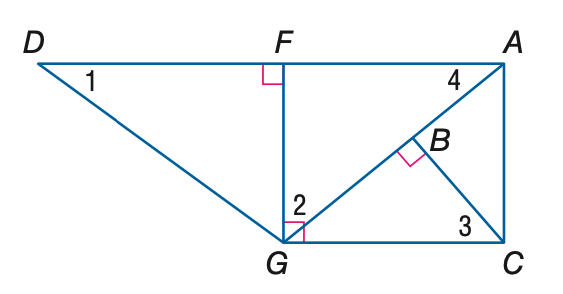Answer the mathemtical geometry problem and directly provide the correct option letter.
Question: Find the measure of \angle 2 if m \angle D G F = 53 and m \angle A G C = 40.
Choices: A: 37 B: 40 C: 50 D: 53 C 